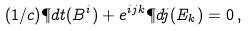<formula> <loc_0><loc_0><loc_500><loc_500>( 1 / c ) \P d { t } ( B ^ { i } ) + e ^ { i j k } \P d { j } ( E _ { k } ) = 0 \, ,</formula> 